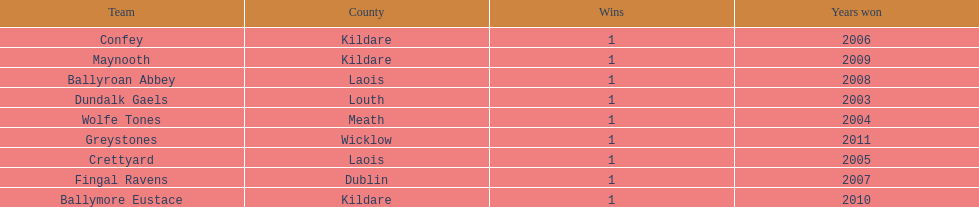How many wins does greystones have? 1. 